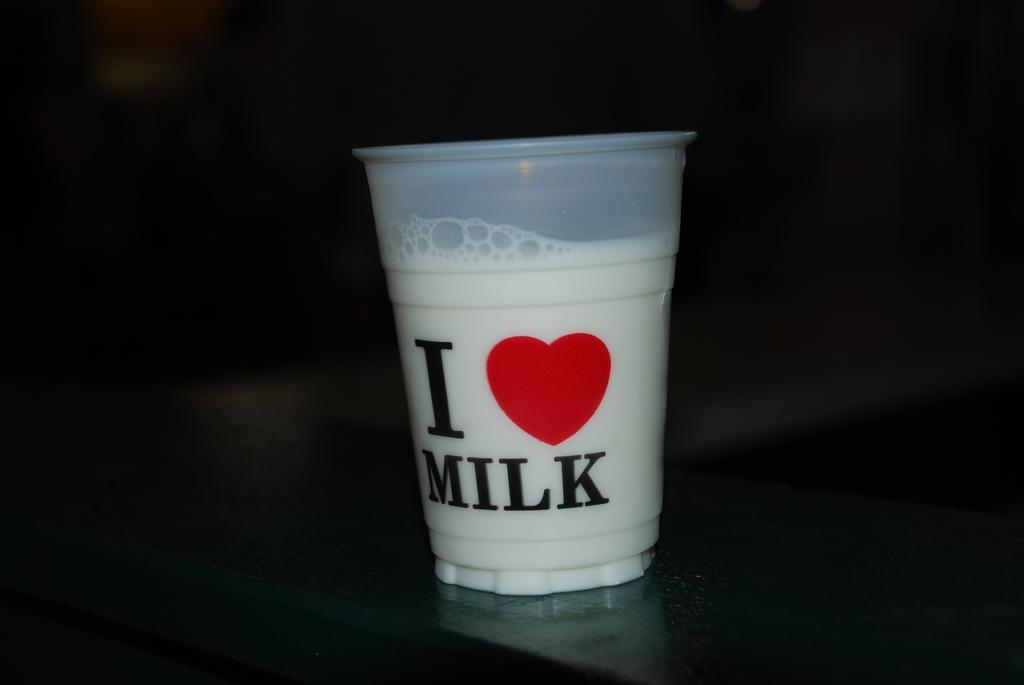<image>
Write a terse but informative summary of the picture. A plastic cup with I love milk message on it. 